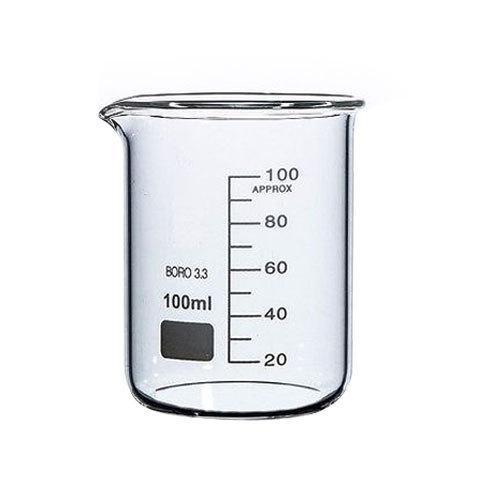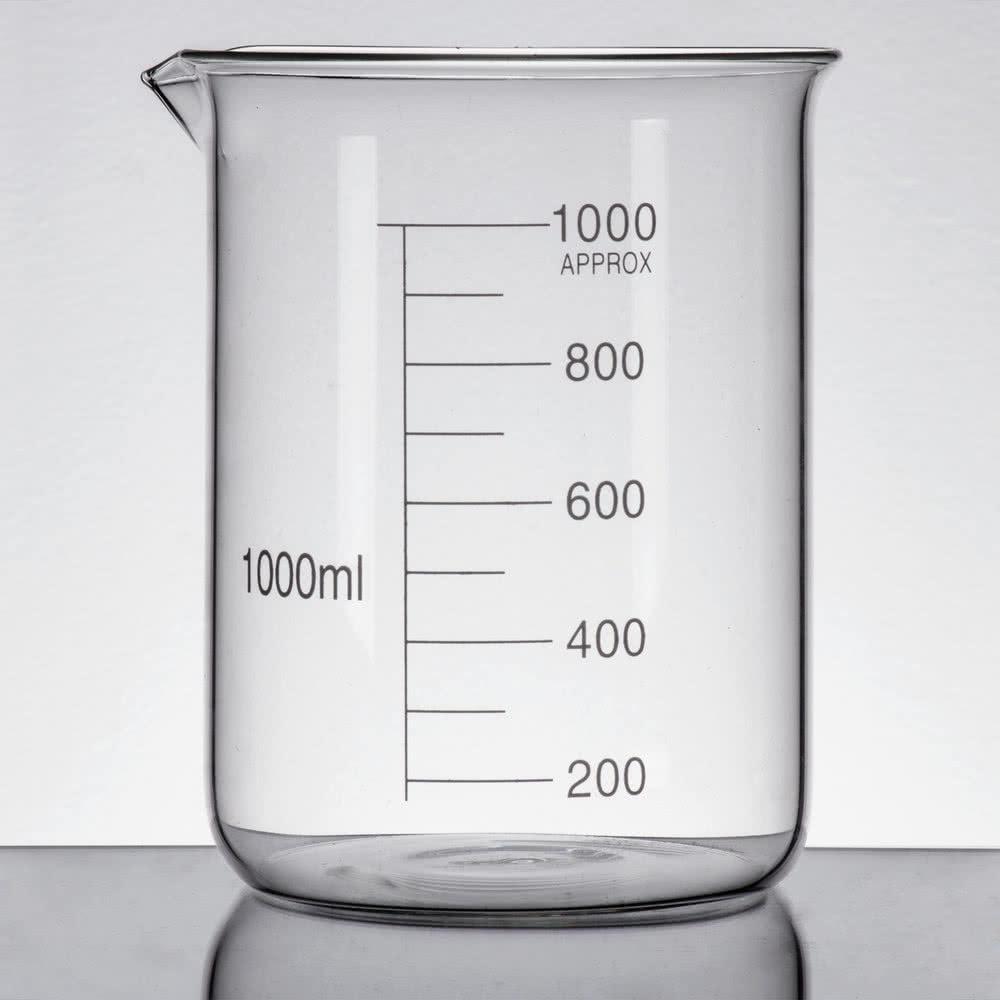The first image is the image on the left, the second image is the image on the right. For the images shown, is this caption "The left and right image contains the same number of beakers." true? Answer yes or no. Yes. The first image is the image on the left, the second image is the image on the right. Assess this claim about the two images: "The right image includes a cylindrical container of blue liquid, and the left image features exactly one container.". Correct or not? Answer yes or no. No. 